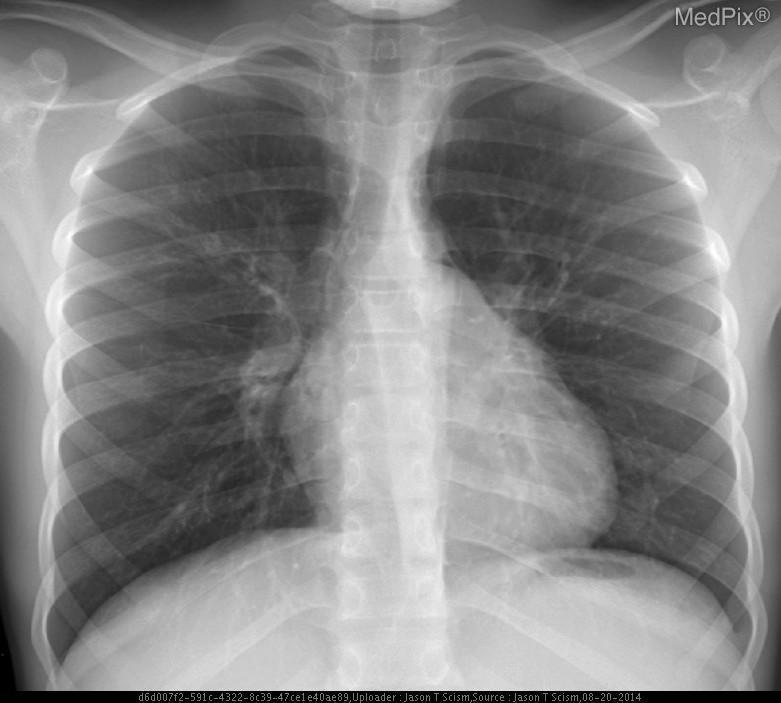Anything abnormal in this image?
Quick response, please. No. Can you appreciate a pleural effusion?
Write a very short answer. No. Is a pleural effusion present?
Keep it brief. No. Is the heart enlarged?
Give a very brief answer. No. Is the heart size increased?
Be succinct. No. Can you diagnose a pericardial effusion from this image?
Write a very short answer. No. Is this image sufficient to diagnose pericardial effusion?
Give a very brief answer. No. 